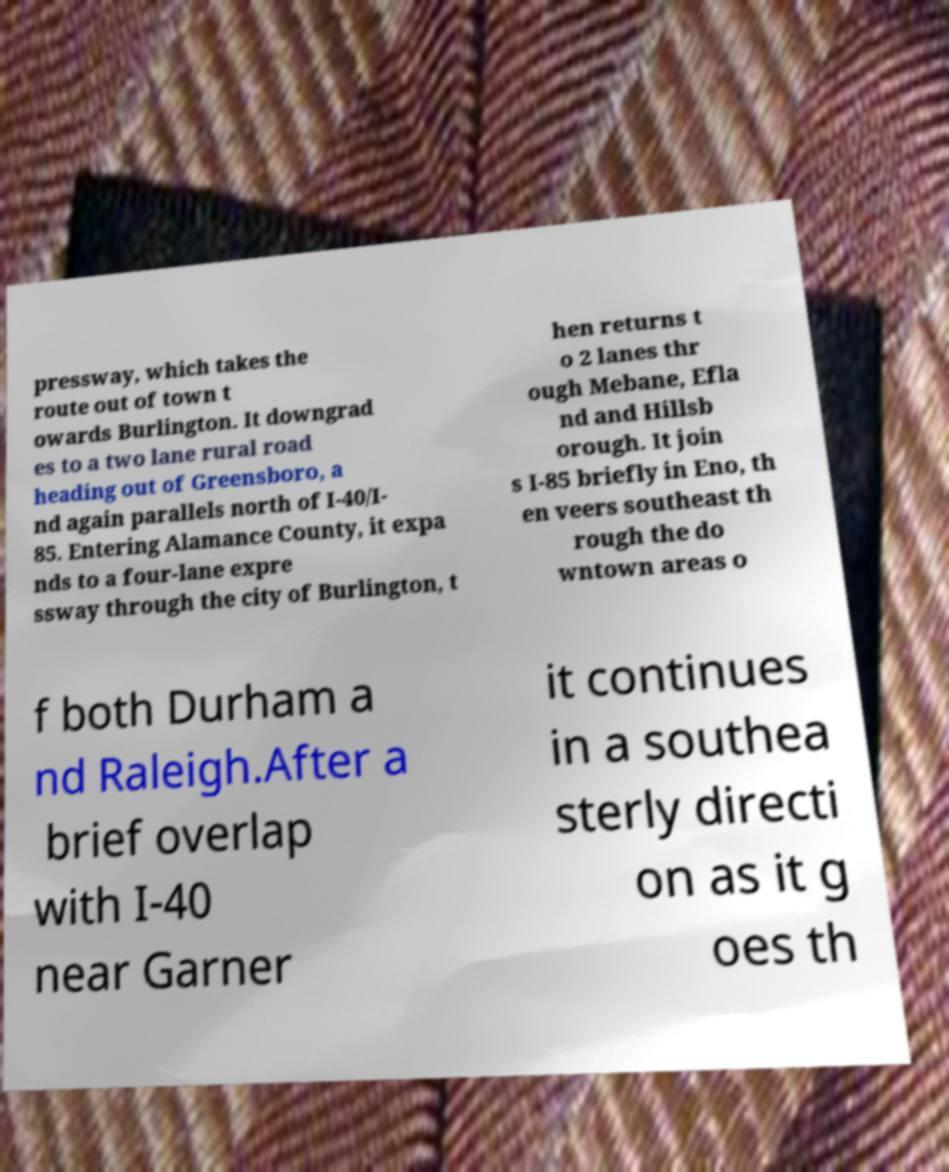What messages or text are displayed in this image? I need them in a readable, typed format. pressway, which takes the route out of town t owards Burlington. It downgrad es to a two lane rural road heading out of Greensboro, a nd again parallels north of I-40/I- 85. Entering Alamance County, it expa nds to a four-lane expre ssway through the city of Burlington, t hen returns t o 2 lanes thr ough Mebane, Efla nd and Hillsb orough. It join s I-85 briefly in Eno, th en veers southeast th rough the do wntown areas o f both Durham a nd Raleigh.After a brief overlap with I-40 near Garner it continues in a southea sterly directi on as it g oes th 